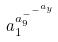Convert formula to latex. <formula><loc_0><loc_0><loc_500><loc_500>a _ { 1 } ^ { a _ { 9 } ^ { - ^ { - ^ { a _ { y } } } } }</formula> 